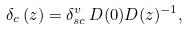Convert formula to latex. <formula><loc_0><loc_0><loc_500><loc_500>\delta _ { c } \left ( z \right ) = \delta _ { s c } ^ { v } \, D ( 0 ) D ( z ) ^ { - 1 } ,</formula> 